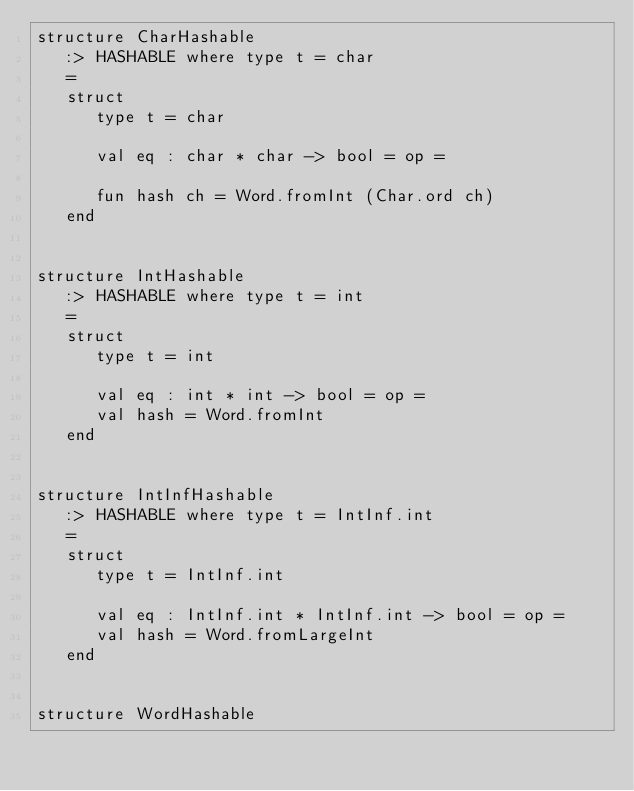<code> <loc_0><loc_0><loc_500><loc_500><_SML_>structure CharHashable
   :> HASHABLE where type t = char
   =
   struct
      type t = char

      val eq : char * char -> bool = op =

      fun hash ch = Word.fromInt (Char.ord ch)
   end


structure IntHashable
   :> HASHABLE where type t = int
   =
   struct
      type t = int

      val eq : int * int -> bool = op =
      val hash = Word.fromInt
   end


structure IntInfHashable
   :> HASHABLE where type t = IntInf.int
   =
   struct
      type t = IntInf.int

      val eq : IntInf.int * IntInf.int -> bool = op =
      val hash = Word.fromLargeInt
   end


structure WordHashable</code> 